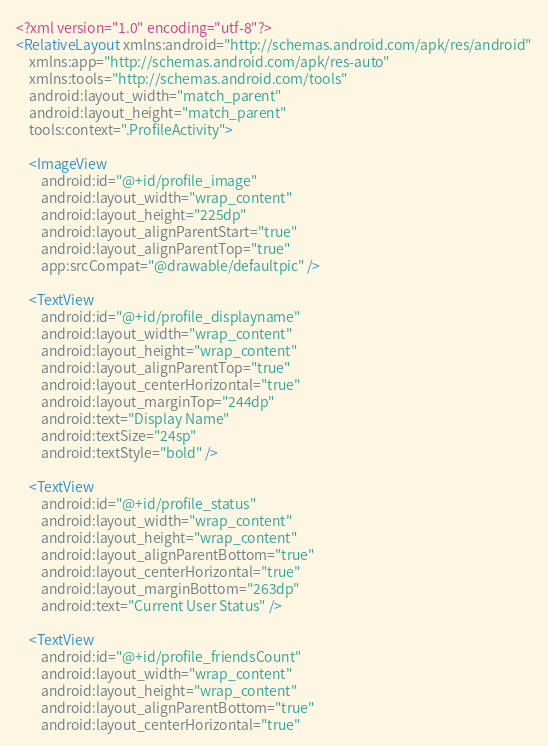Convert code to text. <code><loc_0><loc_0><loc_500><loc_500><_XML_><?xml version="1.0" encoding="utf-8"?>
<RelativeLayout xmlns:android="http://schemas.android.com/apk/res/android"
    xmlns:app="http://schemas.android.com/apk/res-auto"
    xmlns:tools="http://schemas.android.com/tools"
    android:layout_width="match_parent"
    android:layout_height="match_parent"
    tools:context=".ProfileActivity">

    <ImageView
        android:id="@+id/profile_image"
        android:layout_width="wrap_content"
        android:layout_height="225dp"
        android:layout_alignParentStart="true"
        android:layout_alignParentTop="true"
        app:srcCompat="@drawable/defaultpic" />

    <TextView
        android:id="@+id/profile_displayname"
        android:layout_width="wrap_content"
        android:layout_height="wrap_content"
        android:layout_alignParentTop="true"
        android:layout_centerHorizontal="true"
        android:layout_marginTop="244dp"
        android:text="Display Name"
        android:textSize="24sp"
        android:textStyle="bold" />

    <TextView
        android:id="@+id/profile_status"
        android:layout_width="wrap_content"
        android:layout_height="wrap_content"
        android:layout_alignParentBottom="true"
        android:layout_centerHorizontal="true"
        android:layout_marginBottom="263dp"
        android:text="Current User Status" />

    <TextView
        android:id="@+id/profile_friendsCount"
        android:layout_width="wrap_content"
        android:layout_height="wrap_content"
        android:layout_alignParentBottom="true"
        android:layout_centerHorizontal="true"</code> 